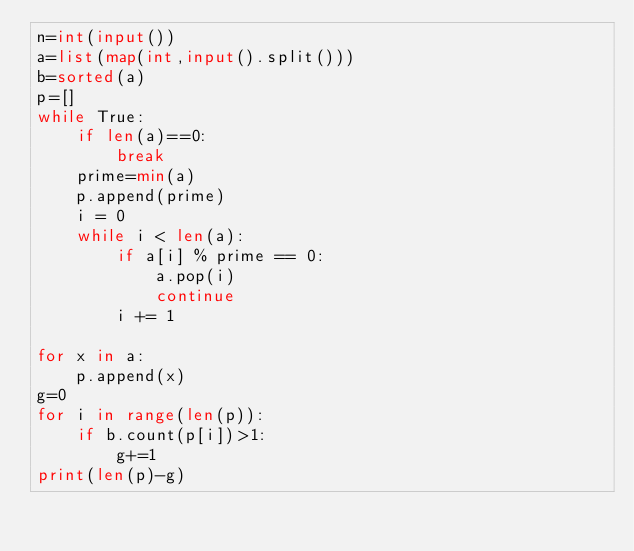Convert code to text. <code><loc_0><loc_0><loc_500><loc_500><_Python_>n=int(input())
a=list(map(int,input().split()))
b=sorted(a)
p=[]
while True:
    if len(a)==0:
        break
    prime=min(a)
    p.append(prime)
    i = 0
    while i < len(a):
        if a[i] % prime == 0:
            a.pop(i)
            continue
        i += 1

for x in a:
    p.append(x)
g=0
for i in range(len(p)):
    if b.count(p[i])>1:
        g+=1
print(len(p)-g)</code> 